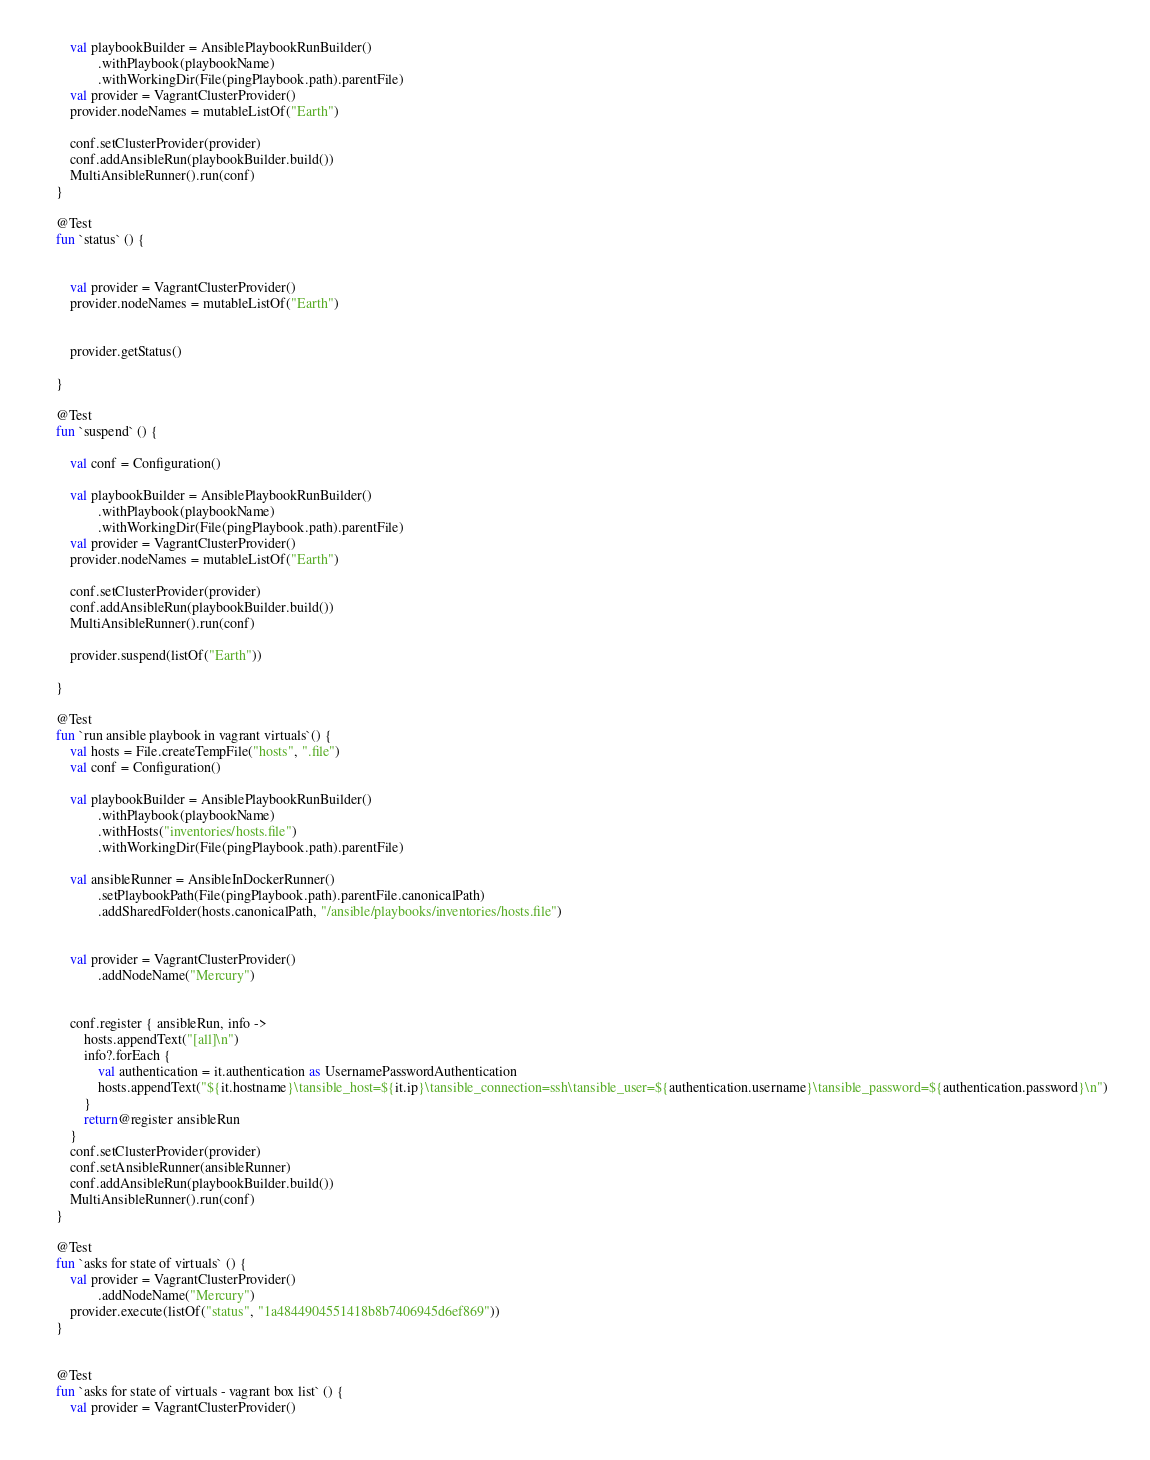<code> <loc_0><loc_0><loc_500><loc_500><_Kotlin_>
        val playbookBuilder = AnsiblePlaybookRunBuilder()
                .withPlaybook(playbookName)
                .withWorkingDir(File(pingPlaybook.path).parentFile)
        val provider = VagrantClusterProvider()
        provider.nodeNames = mutableListOf("Earth")

        conf.setClusterProvider(provider)
        conf.addAnsibleRun(playbookBuilder.build())
        MultiAnsibleRunner().run(conf)
    }

    @Test
    fun `status` () {


        val provider = VagrantClusterProvider()
        provider.nodeNames = mutableListOf("Earth")


        provider.getStatus()

    }

    @Test
    fun `suspend` () {

        val conf = Configuration()

        val playbookBuilder = AnsiblePlaybookRunBuilder()
                .withPlaybook(playbookName)
                .withWorkingDir(File(pingPlaybook.path).parentFile)
        val provider = VagrantClusterProvider()
        provider.nodeNames = mutableListOf("Earth")

        conf.setClusterProvider(provider)
        conf.addAnsibleRun(playbookBuilder.build())
        MultiAnsibleRunner().run(conf)

        provider.suspend(listOf("Earth"))

    }

    @Test
    fun `run ansible playbook in vagrant virtuals`() {
        val hosts = File.createTempFile("hosts", ".file")
        val conf = Configuration()

        val playbookBuilder = AnsiblePlaybookRunBuilder()
                .withPlaybook(playbookName)
                .withHosts("inventories/hosts.file")
                .withWorkingDir(File(pingPlaybook.path).parentFile)

        val ansibleRunner = AnsibleInDockerRunner()
                .setPlaybookPath(File(pingPlaybook.path).parentFile.canonicalPath)
                .addSharedFolder(hosts.canonicalPath, "/ansible/playbooks/inventories/hosts.file")


        val provider = VagrantClusterProvider()
                .addNodeName("Mercury")


        conf.register { ansibleRun, info ->
            hosts.appendText("[all]\n")
            info?.forEach {
                val authentication = it.authentication as UsernamePasswordAuthentication
                hosts.appendText("${it.hostname}\tansible_host=${it.ip}\tansible_connection=ssh\tansible_user=${authentication.username}\tansible_password=${authentication.password}\n")
            }
            return@register ansibleRun
        }
        conf.setClusterProvider(provider)
        conf.setAnsibleRunner(ansibleRunner)
        conf.addAnsibleRun(playbookBuilder.build())
        MultiAnsibleRunner().run(conf)
    }

    @Test
    fun `asks for state of virtuals` () {
        val provider = VagrantClusterProvider()
                .addNodeName("Mercury")
        provider.execute(listOf("status", "1a4844904551418b8b7406945d6ef869"))
    }


    @Test
    fun `asks for state of virtuals - vagrant box list` () {
        val provider = VagrantClusterProvider()</code> 